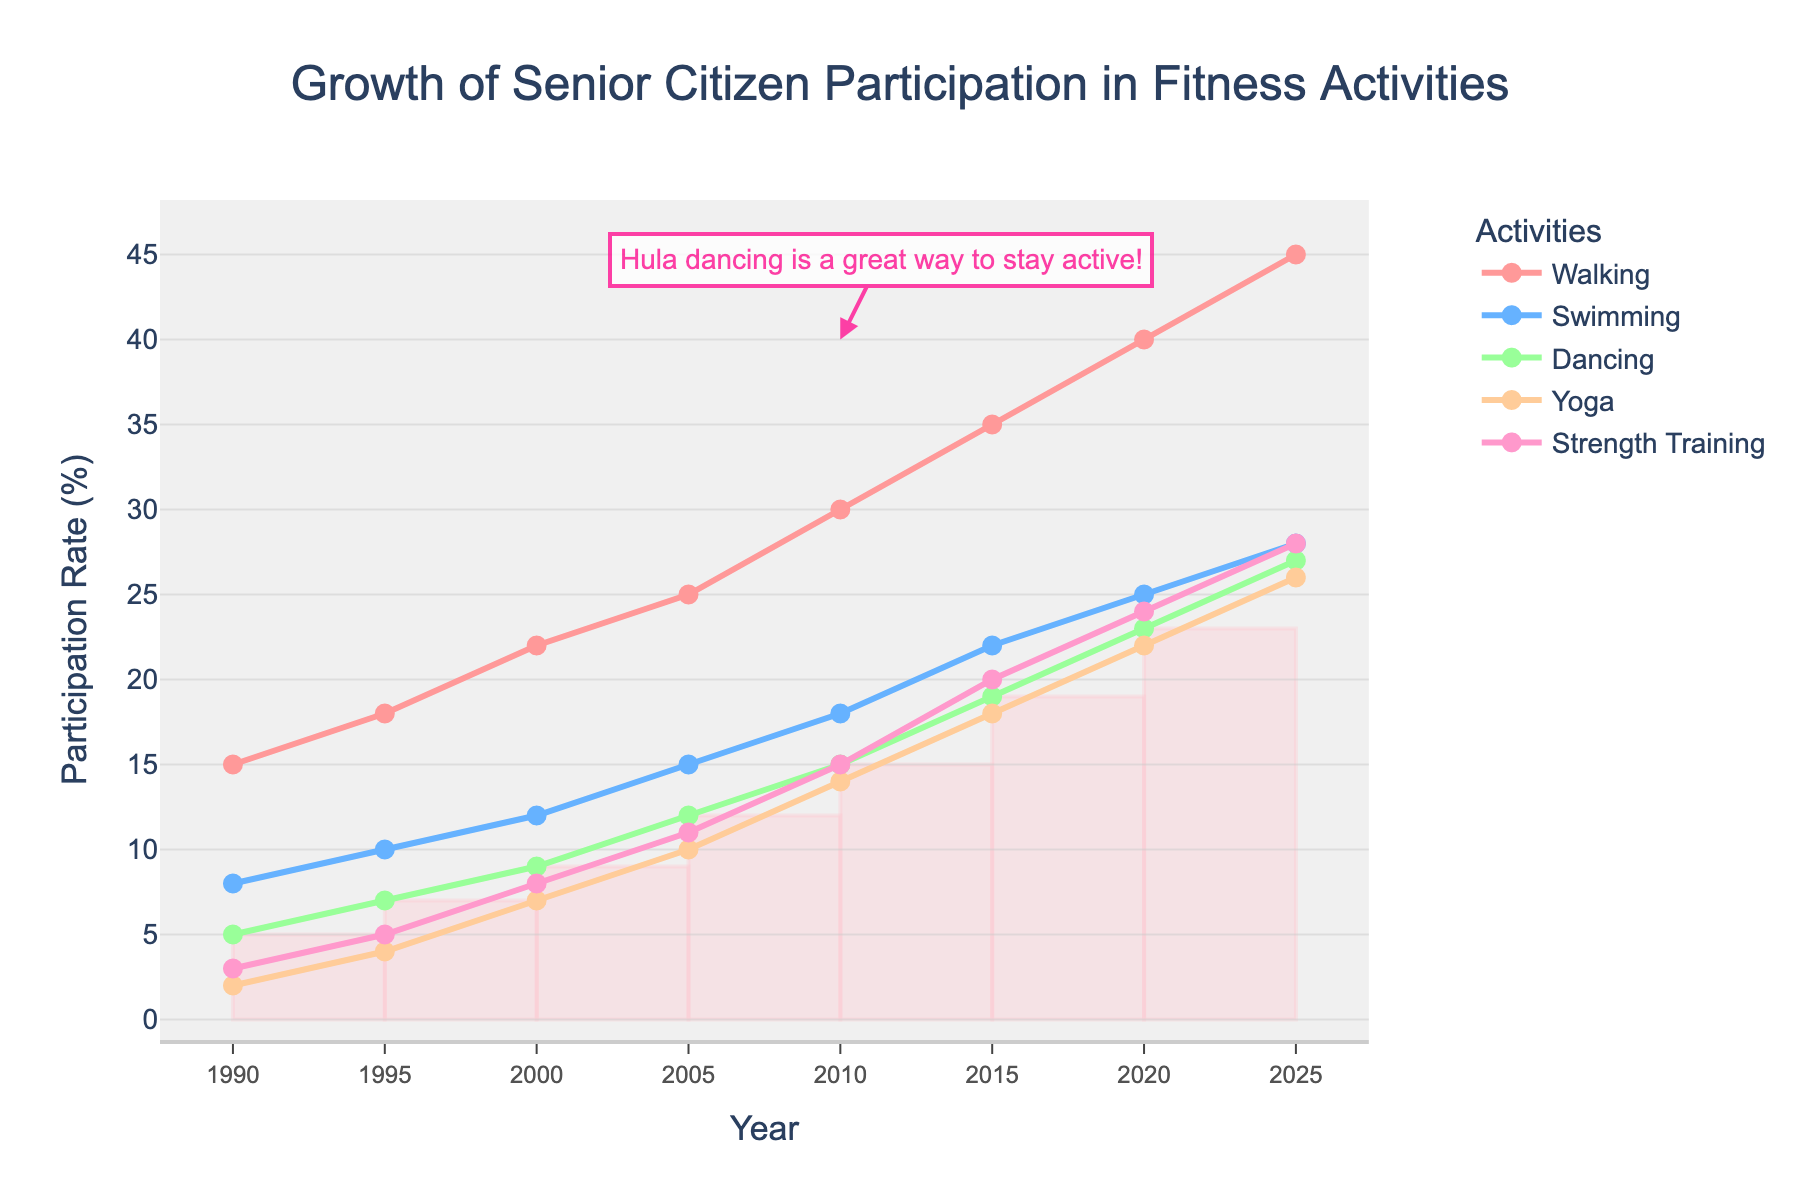What activity had the highest participation rate in 2025? Look at the 2025 markers on the lines representing each activity in the figure. Walking reaches the highest point among all.
Answer: Walking Between which years did Yoga see the largest increase in participation? Identify the steepest increase on the Yoga line (green) by examining the slope between each pair of adjacent years. The largest increase happens between 2000 and 2005.
Answer: 2000 to 2005 How much did Dancing participation rate increase from 1990 to 2020? Subtract the participation rate for Dancing in 1990 from that in 2020 as shown by the pink line: 23 (in 2020) - 5 (in 1990).
Answer: 18 For which activity is the increase in participation from 2000 to 2025 the smallest? Calculate the difference in participation rates for each activity between 2000 and 2025, then identify the smallest difference. Yoga has the smallest increase from 7 to 26, an increment of 19.
Answer: Yoga In what year did Swimming surpass a 20% participation rate? Observe the point at which the blue line (Swimming) surpasses the 20% mark on the y-axis. This occurs between 2010 and 2015.
Answer: 2015 Which activity experienced the most consistent growth over the years? Analyze the smoothness and consistency of the slope for each activity over the years. Walking (red) exhibits a steady and consistent increase.
Answer: Walking What is the total increase in participation for all activities combined from 1990 to 2025? Sum the increase in participation rates for all activities from 1990 to 2025: (Walking: 45-15) + (Swimming: 28-8) + (Dancing: 27-5) + (Yoga: 26-2) + (Strength Training: 28-3) = 30+20+22+24+25.
Answer: 121 When did Dancing participation reach 15%, and what was the participation rate of Yoga at the same time? Identify the year Dancing first reached 15% and check Yoga's rate in that year. Dancing reached 15% in 2010, and Yoga had a 14% participation rate that year.
Answer: 2010, 14% Which activity had the slowest growth from 2010 to 2020? Check the differences in participation rates for each activity between 2010 and 2020, where Yoga's change from 14 to 22 (8%) is the smallest.
Answer: Yoga On which year does the annotation appear and what does it highlight regarding the chart? Find the annotation in the chart. It appears near 2010 and highlights the benefit of Hula dancing.
Answer: 2010, Hula dancing benefits 